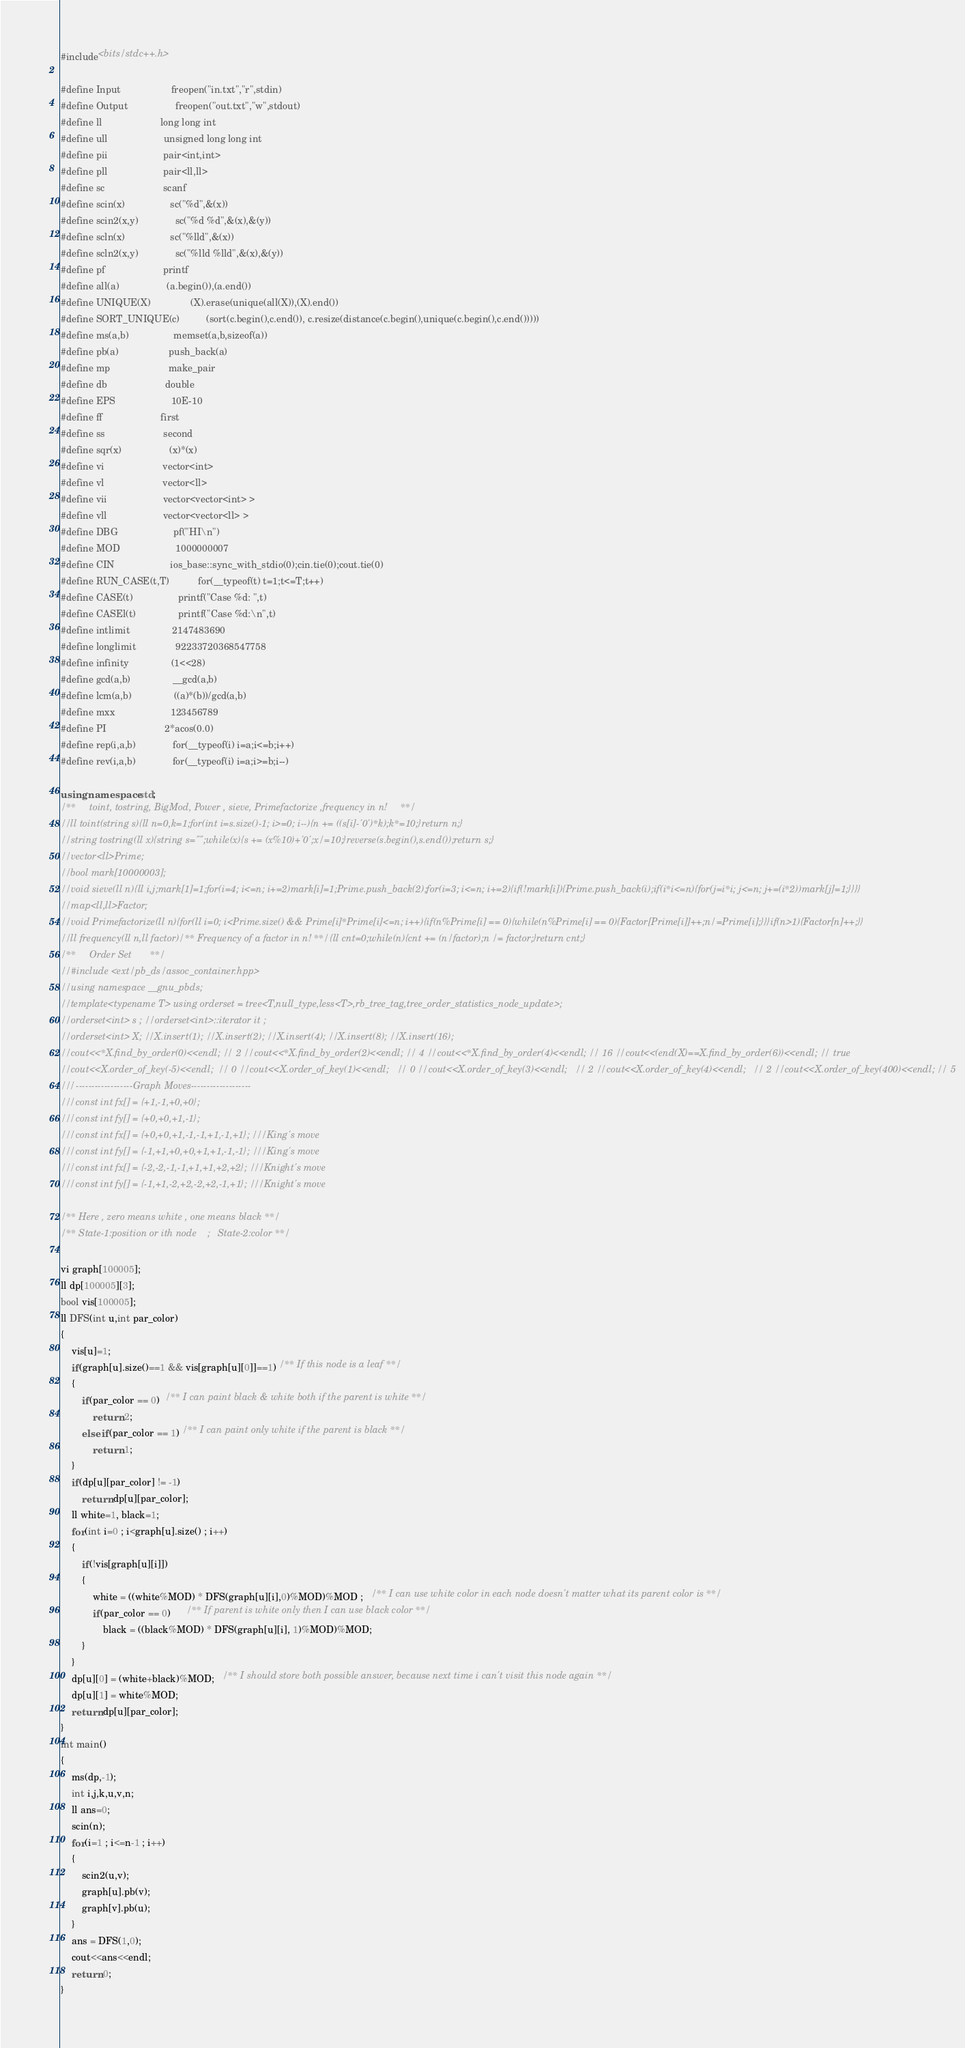<code> <loc_0><loc_0><loc_500><loc_500><_C++_>#include<bits/stdc++.h>

#define Input                   freopen("in.txt","r",stdin)
#define Output                  freopen("out.txt","w",stdout)
#define ll                      long long int
#define ull                     unsigned long long int
#define pii                     pair<int,int>
#define pll                     pair<ll,ll>
#define sc                      scanf
#define scin(x)                 sc("%d",&(x))
#define scin2(x,y)              sc("%d %d",&(x),&(y))
#define scln(x)                 sc("%lld",&(x))
#define scln2(x,y)              sc("%lld %lld",&(x),&(y))
#define pf                      printf
#define all(a)                  (a.begin()),(a.end())
#define UNIQUE(X)               (X).erase(unique(all(X)),(X).end())
#define SORT_UNIQUE(c)          (sort(c.begin(),c.end()), c.resize(distance(c.begin(),unique(c.begin(),c.end()))))
#define ms(a,b)                 memset(a,b,sizeof(a))
#define pb(a)                   push_back(a)
#define mp                      make_pair
#define db                      double
#define EPS                     10E-10
#define ff                      first
#define ss                      second
#define sqr(x)                  (x)*(x)
#define vi                      vector<int>
#define vl                      vector<ll>
#define vii                     vector<vector<int> >
#define vll                     vector<vector<ll> >
#define DBG                     pf("HI\n")
#define MOD                     1000000007
#define CIN                     ios_base::sync_with_stdio(0);cin.tie(0);cout.tie(0)
#define RUN_CASE(t,T)           for(__typeof(t) t=1;t<=T;t++)
#define CASE(t)                 printf("Case %d: ",t)
#define CASEl(t)                printf("Case %d:\n",t)
#define intlimit                2147483690
#define longlimit               92233720368547758
#define infinity                (1<<28)
#define gcd(a,b)                __gcd(a,b)
#define lcm(a,b)                ((a)*(b))/gcd(a,b)
#define mxx                     123456789
#define PI                      2*acos(0.0)
#define rep(i,a,b)              for(__typeof(i) i=a;i<=b;i++)
#define rev(i,a,b)              for(__typeof(i) i=a;i>=b;i--)

using namespace std;
/**     toint, tostring, BigMod, Power , sieve, Primefactorize ,frequency in n!     **/
//ll toint(string s){ll n=0,k=1;for(int i=s.size()-1; i>=0; i--){n += ((s[i]-'0')*k);k*=10;}return n;}
//string tostring(ll x){string s="";while(x){s += (x%10)+'0';x/=10;}reverse(s.begin(),s.end());return s;}
//vector<ll>Prime;
//bool mark[10000003];
//void sieve(ll n){ll i,j;mark[1]=1;for(i=4; i<=n; i+=2)mark[i]=1;Prime.push_back(2);for(i=3; i<=n; i+=2){if(!mark[i]){Prime.push_back(i);if(i*i<=n){for(j=i*i; j<=n; j+=(i*2))mark[j]=1;}}}}
//map<ll,ll>Factor;
//void Primefactorize(ll n){for(ll i=0; i<Prime.size() && Prime[i]*Prime[i]<=n; i++){if(n%Prime[i] == 0){while(n%Prime[i] == 0){Factor[Prime[i]]++;n/=Prime[i];}}}if(n>1){Factor[n]++;}}
//ll frequency(ll n,ll factor)/** Frequency of a factor in n! **/{ll cnt=0;while(n){cnt += (n/factor);n /= factor;}return cnt;}
/**     Order Set       **/
//#include <ext/pb_ds/assoc_container.hpp>
//using namespace __gnu_pbds;
//template<typename T> using orderset = tree<T,null_type,less<T>,rb_tree_tag,tree_order_statistics_node_update>;
//orderset<int> s ; //orderset<int>::iterator it ;
//orderset<int> X; //X.insert(1); //X.insert(2); //X.insert(4); //X.insert(8); //X.insert(16);
//cout<<*X.find_by_order(0)<<endl; // 2 //cout<<*X.find_by_order(2)<<endl; // 4 //cout<<*X.find_by_order(4)<<endl; // 16 //cout<<(end(X)==X.find_by_order(6))<<endl; // true
//cout<<X.order_of_key(-5)<<endl;  // 0 //cout<<X.order_of_key(1)<<endl;   // 0 //cout<<X.order_of_key(3)<<endl;   // 2 //cout<<X.order_of_key(4)<<endl;   // 2 //cout<<X.order_of_key(400)<<endl; // 5
///------------------Graph Moves-------------------
///const int fx[] = {+1,-1,+0,+0};
///const int fy[] = {+0,+0,+1,-1};
///const int fx[] = {+0,+0,+1,-1,-1,+1,-1,+1}; ///King's move
///const int fy[] = {-1,+1,+0,+0,+1,+1,-1,-1}; ///King's move
///const int fx[] = {-2,-2,-1,-1,+1,+1,+2,+2}; ///Knight's move
///const int fy[] = {-1,+1,-2,+2,-2,+2,-1,+1}; ///Knight's move

/** Here , zero means white , one means black **/
/** State-1:position or ith node    ;   State-2:color **/

vi graph[100005];
ll dp[100005][3];
bool vis[100005];
ll DFS(int u,int par_color)
{
    vis[u]=1;
    if(graph[u].size()==1 && vis[graph[u][0]]==1) /** If this node is a leaf **/
    {
        if(par_color == 0)  /** I can paint black & white both if the parent is white **/
            return 2;
        else if(par_color == 1) /** I can paint only white if the parent is black **/
            return 1;
    }
    if(dp[u][par_color] != -1)
        return dp[u][par_color];
    ll white=1, black=1;
    for(int i=0 ; i<graph[u].size() ; i++)
    {
        if(!vis[graph[u][i]])
        {
            white = ((white%MOD) * DFS(graph[u][i],0)%MOD)%MOD ;   /** I can use white color in each node doesn't matter what its parent color is **/
            if(par_color == 0)      /** If parent is white only then I can use black color **/
                black = ((black%MOD) * DFS(graph[u][i], 1)%MOD)%MOD;
        }
    }
    dp[u][0] = (white+black)%MOD;   /** I should store both possible answer, because next time i can't visit this node again **/
    dp[u][1] = white%MOD;
    return dp[u][par_color];
}
int main()
{
    ms(dp,-1);
    int i,j,k,u,v,n;
    ll ans=0;
    scin(n);
    for(i=1 ; i<=n-1 ; i++)
    {
        scin2(u,v);
        graph[u].pb(v);
        graph[v].pb(u);
    }
    ans = DFS(1,0);
    cout<<ans<<endl;
    return 0;
}

</code> 